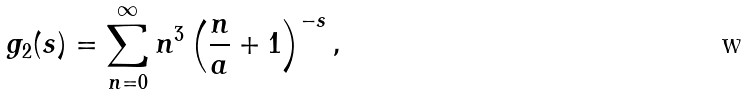<formula> <loc_0><loc_0><loc_500><loc_500>g _ { 2 } ( s ) = \sum _ { n = 0 } ^ { \infty } n ^ { 3 } \left ( \frac { n } { a } + 1 \right ) ^ { - s } ,</formula> 